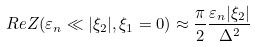Convert formula to latex. <formula><loc_0><loc_0><loc_500><loc_500>R e Z ( \varepsilon _ { n } \ll | \xi _ { 2 } | , \xi _ { 1 } = 0 ) \approx \frac { \pi } { 2 } \frac { \varepsilon _ { n } | \xi _ { 2 } | } { \Delta ^ { 2 } }</formula> 